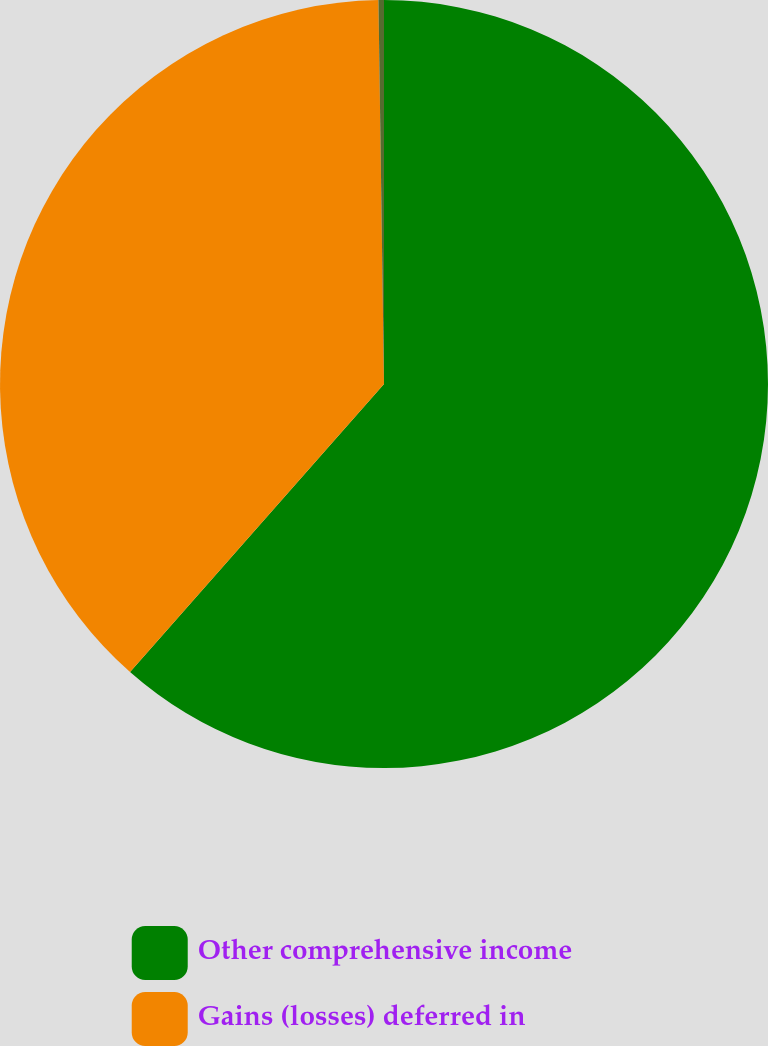Convert chart. <chart><loc_0><loc_0><loc_500><loc_500><pie_chart><fcel>Other comprehensive income<fcel>Gains (losses) deferred in<fcel>Unnamed: 2<nl><fcel>61.5%<fcel>38.27%<fcel>0.23%<nl></chart> 